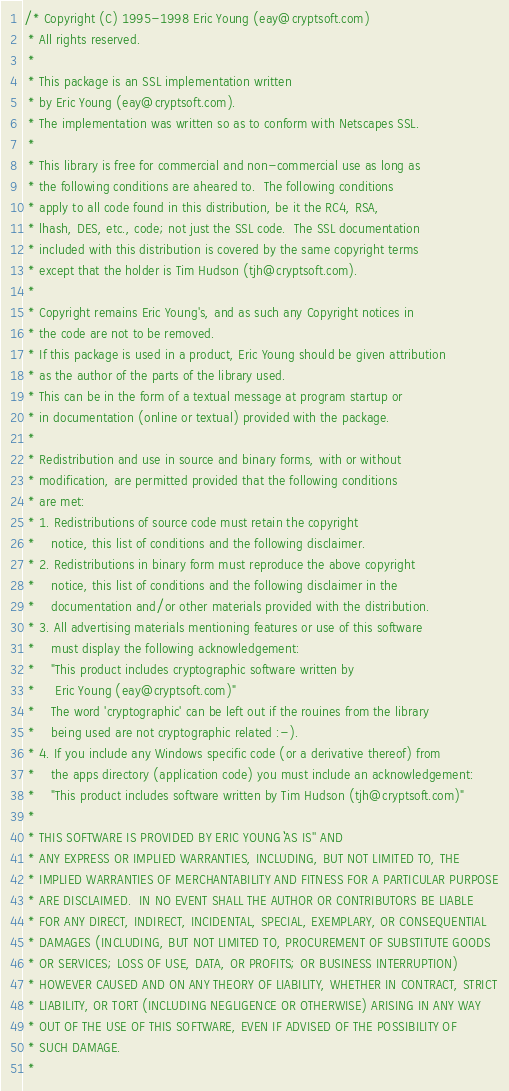Convert code to text. <code><loc_0><loc_0><loc_500><loc_500><_C_>/* Copyright (C) 1995-1998 Eric Young (eay@cryptsoft.com)
 * All rights reserved.
 *
 * This package is an SSL implementation written
 * by Eric Young (eay@cryptsoft.com).
 * The implementation was written so as to conform with Netscapes SSL.
 *
 * This library is free for commercial and non-commercial use as long as
 * the following conditions are aheared to.  The following conditions
 * apply to all code found in this distribution, be it the RC4, RSA,
 * lhash, DES, etc., code; not just the SSL code.  The SSL documentation
 * included with this distribution is covered by the same copyright terms
 * except that the holder is Tim Hudson (tjh@cryptsoft.com).
 *
 * Copyright remains Eric Young's, and as such any Copyright notices in
 * the code are not to be removed.
 * If this package is used in a product, Eric Young should be given attribution
 * as the author of the parts of the library used.
 * This can be in the form of a textual message at program startup or
 * in documentation (online or textual) provided with the package.
 *
 * Redistribution and use in source and binary forms, with or without
 * modification, are permitted provided that the following conditions
 * are met:
 * 1. Redistributions of source code must retain the copyright
 *    notice, this list of conditions and the following disclaimer.
 * 2. Redistributions in binary form must reproduce the above copyright
 *    notice, this list of conditions and the following disclaimer in the
 *    documentation and/or other materials provided with the distribution.
 * 3. All advertising materials mentioning features or use of this software
 *    must display the following acknowledgement:
 *    "This product includes cryptographic software written by
 *     Eric Young (eay@cryptsoft.com)"
 *    The word 'cryptographic' can be left out if the rouines from the library
 *    being used are not cryptographic related :-).
 * 4. If you include any Windows specific code (or a derivative thereof) from
 *    the apps directory (application code) you must include an acknowledgement:
 *    "This product includes software written by Tim Hudson (tjh@cryptsoft.com)"
 *
 * THIS SOFTWARE IS PROVIDED BY ERIC YOUNG ``AS IS'' AND
 * ANY EXPRESS OR IMPLIED WARRANTIES, INCLUDING, BUT NOT LIMITED TO, THE
 * IMPLIED WARRANTIES OF MERCHANTABILITY AND FITNESS FOR A PARTICULAR PURPOSE
 * ARE DISCLAIMED.  IN NO EVENT SHALL THE AUTHOR OR CONTRIBUTORS BE LIABLE
 * FOR ANY DIRECT, INDIRECT, INCIDENTAL, SPECIAL, EXEMPLARY, OR CONSEQUENTIAL
 * DAMAGES (INCLUDING, BUT NOT LIMITED TO, PROCUREMENT OF SUBSTITUTE GOODS
 * OR SERVICES; LOSS OF USE, DATA, OR PROFITS; OR BUSINESS INTERRUPTION)
 * HOWEVER CAUSED AND ON ANY THEORY OF LIABILITY, WHETHER IN CONTRACT, STRICT
 * LIABILITY, OR TORT (INCLUDING NEGLIGENCE OR OTHERWISE) ARISING IN ANY WAY
 * OUT OF THE USE OF THIS SOFTWARE, EVEN IF ADVISED OF THE POSSIBILITY OF
 * SUCH DAMAGE.
 *</code> 